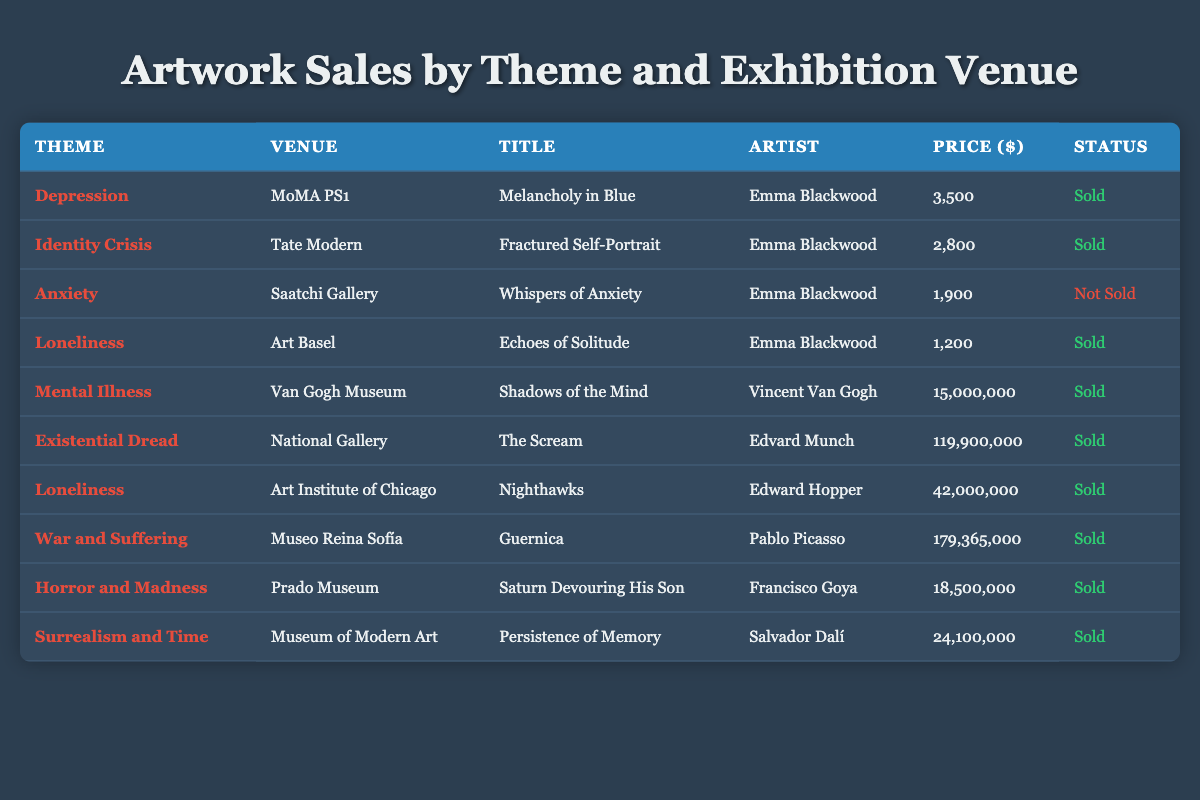What is the title of the artwork sold at MoMA PS1? Referring to the table, the artwork sold at MoMA PS1 has the title "Melancholy in Blue."
Answer: Melancholy in Blue Who is the artist of "Guernica"? From the table, "Guernica" is attributed to the artist Pablo Picasso.
Answer: Pablo Picasso How many artworks listed have been sold? By counting the rows labeled as "Sold," we find that there are 9 artworks that have been sold.
Answer: 9 What is the price of "The Scream"? The table indicates that the price of "The Scream" is 119,900,000.
Answer: 119,900,000 Is there any artwork with the theme of Anxiety that was sold? The table indicates that "Whispers of Anxiety" is not sold, which means there is no sold artwork with that theme.
Answer: No What is the average price of all the sold artworks? To find the average price of the sold artworks, we sum the prices of the sold pieces: 3,500 + 2,800 + 1,200 + 15,000,000 + 119,900,000 + 42,000,000 + 179,365,000 + 18,500,000 + 24,100,000 =  364,571,500. There are 9 sold artworks, so the average price is 364,571,500 / 9 ≈ 40,514,611.11.
Answer: Approximately 40,514,611.11 What venue showcased the theme of Loneliness? The table shows that there are two artworks themed around Loneliness. They were showcased at Art Basel and the Art Institute of Chicago.
Answer: Art Basel and Art Institute of Chicago How many different themes are represented in the table? By reviewing the unique themes listed in the table, we find there are 8 different themes.
Answer: 8 Does the artwork "Persistence of Memory" belong to the theme of Mental Illness? The table classifies "Persistence of Memory" under the theme of Surrealism and Time, not Mental Illness, which confirms this fact is false.
Answer: No 